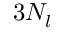Convert formula to latex. <formula><loc_0><loc_0><loc_500><loc_500>3 N _ { l }</formula> 